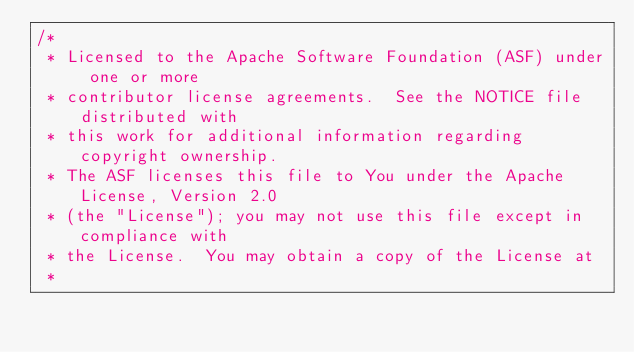Convert code to text. <code><loc_0><loc_0><loc_500><loc_500><_Scala_>/*
 * Licensed to the Apache Software Foundation (ASF) under one or more
 * contributor license agreements.  See the NOTICE file distributed with
 * this work for additional information regarding copyright ownership.
 * The ASF licenses this file to You under the Apache License, Version 2.0
 * (the "License"); you may not use this file except in compliance with
 * the License.  You may obtain a copy of the License at
 *</code> 